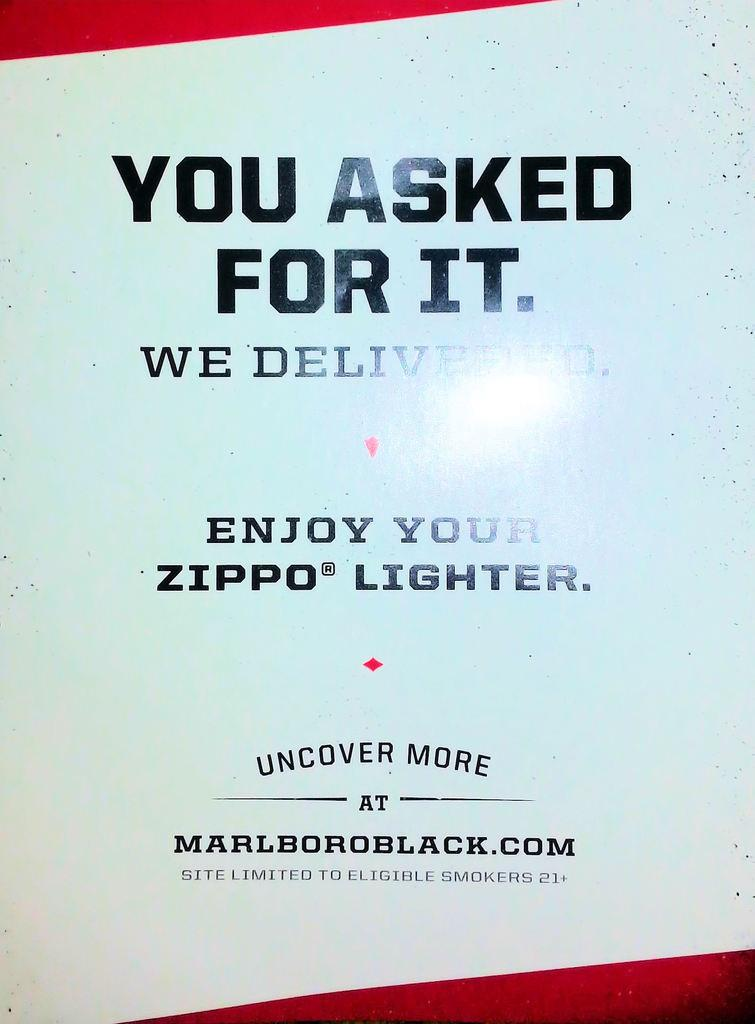<image>
Relay a brief, clear account of the picture shown. A simple zippo lighter advertisement shows the logo, "you asked for it." 